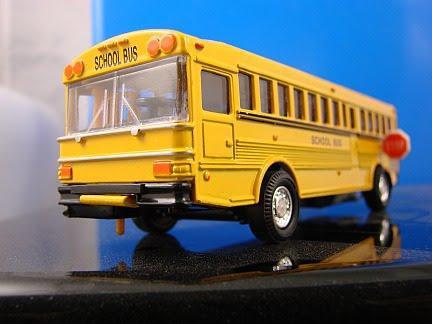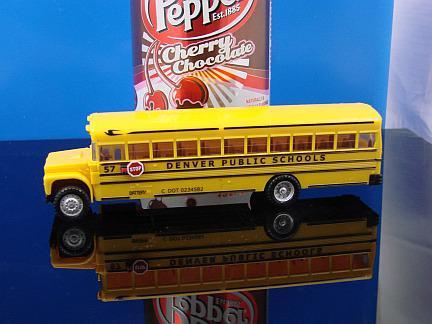The first image is the image on the left, the second image is the image on the right. For the images displayed, is the sentence "A bus' left side is visible." factually correct? Answer yes or no. Yes. The first image is the image on the left, the second image is the image on the right. Analyze the images presented: Is the assertion "At least one bus has a red stop sign." valid? Answer yes or no. Yes. 